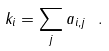Convert formula to latex. <formula><loc_0><loc_0><loc_500><loc_500>k _ { i } = \sum _ { j } a _ { i , j } \ .</formula> 